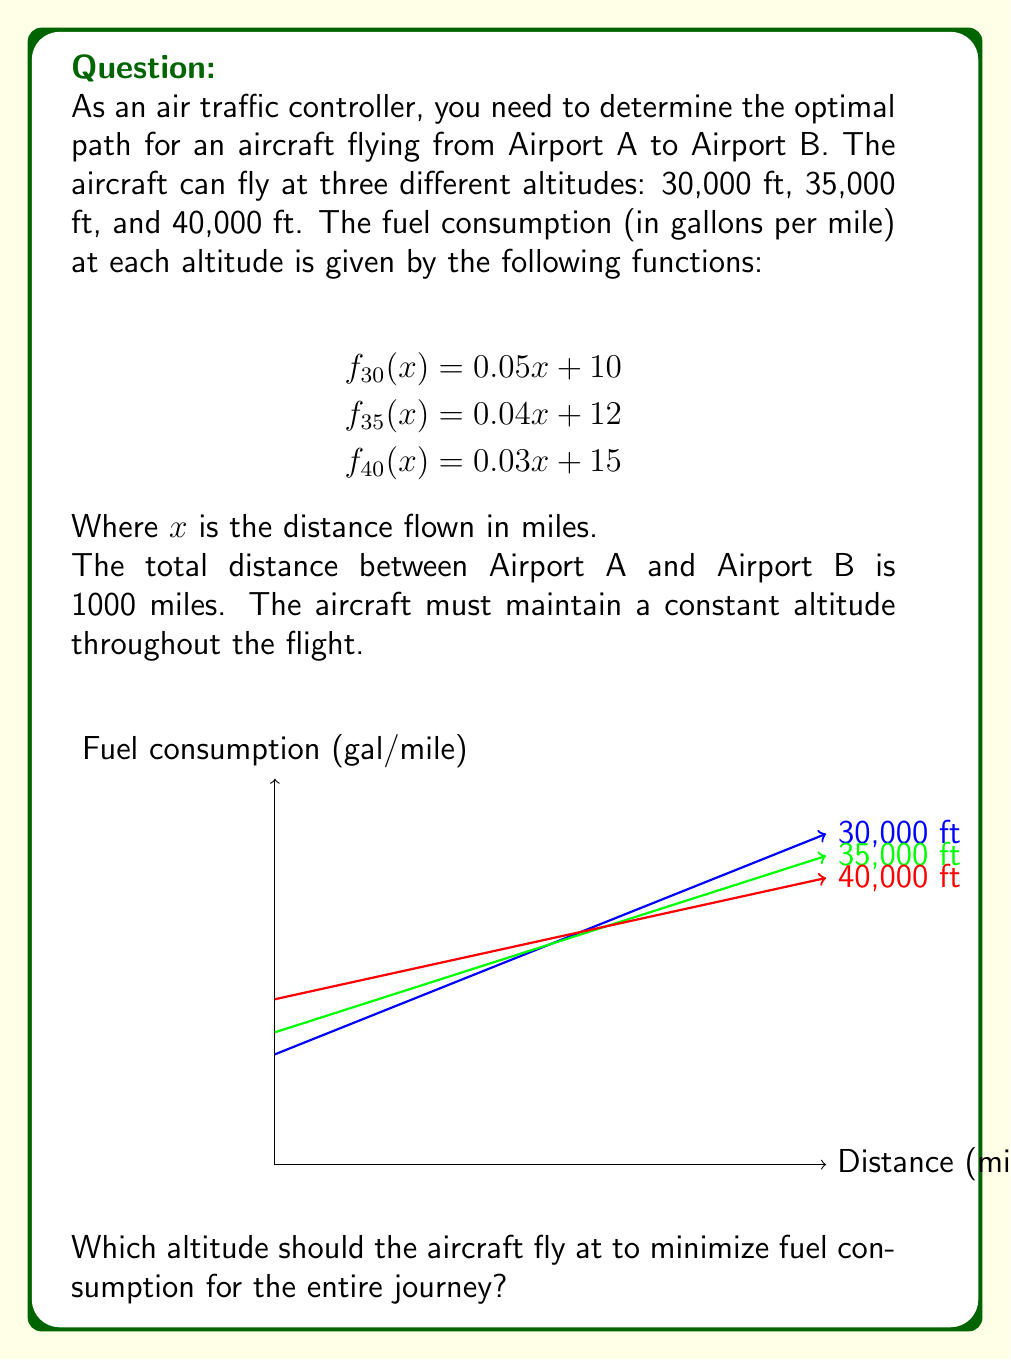Teach me how to tackle this problem. To solve this problem, we need to calculate the total fuel consumption for the entire 1000-mile journey at each altitude:

1. For 30,000 ft:
   $F_{30} = \int_0^{1000} (0.05x + 10) dx$
   $= [0.025x^2 + 10x]_0^{1000}$
   $= (25000 + 10000) - (0 + 0) = 35000$ gallons

2. For 35,000 ft:
   $F_{35} = \int_0^{1000} (0.04x + 12) dx$
   $= [0.02x^2 + 12x]_0^{1000}$
   $= (20000 + 12000) - (0 + 0) = 32000$ gallons

3. For 40,000 ft:
   $F_{40} = \int_0^{1000} (0.03x + 15) dx$
   $= [0.015x^2 + 15x]_0^{1000}$
   $= (15000 + 15000) - (0 + 0) = 30000$ gallons

Comparing the results:
$F_{40} < F_{35} < F_{30}$

Therefore, flying at 40,000 ft consumes the least amount of fuel for the entire journey.
Answer: 40,000 ft 